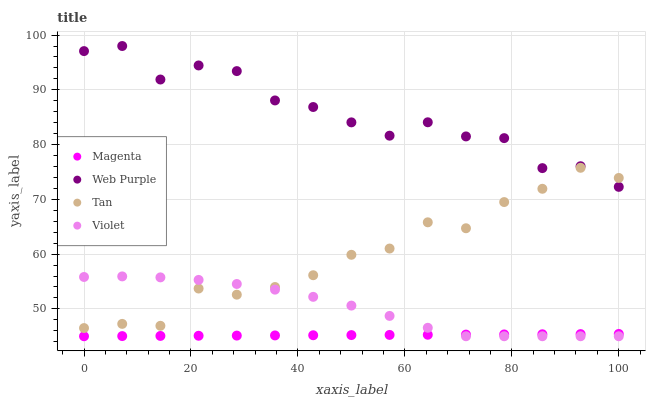Does Magenta have the minimum area under the curve?
Answer yes or no. Yes. Does Web Purple have the maximum area under the curve?
Answer yes or no. Yes. Does Tan have the minimum area under the curve?
Answer yes or no. No. Does Tan have the maximum area under the curve?
Answer yes or no. No. Is Magenta the smoothest?
Answer yes or no. Yes. Is Web Purple the roughest?
Answer yes or no. Yes. Is Tan the smoothest?
Answer yes or no. No. Is Tan the roughest?
Answer yes or no. No. Does Magenta have the lowest value?
Answer yes or no. Yes. Does Tan have the lowest value?
Answer yes or no. No. Does Web Purple have the highest value?
Answer yes or no. Yes. Does Tan have the highest value?
Answer yes or no. No. Is Magenta less than Web Purple?
Answer yes or no. Yes. Is Web Purple greater than Magenta?
Answer yes or no. Yes. Does Tan intersect Violet?
Answer yes or no. Yes. Is Tan less than Violet?
Answer yes or no. No. Is Tan greater than Violet?
Answer yes or no. No. Does Magenta intersect Web Purple?
Answer yes or no. No. 